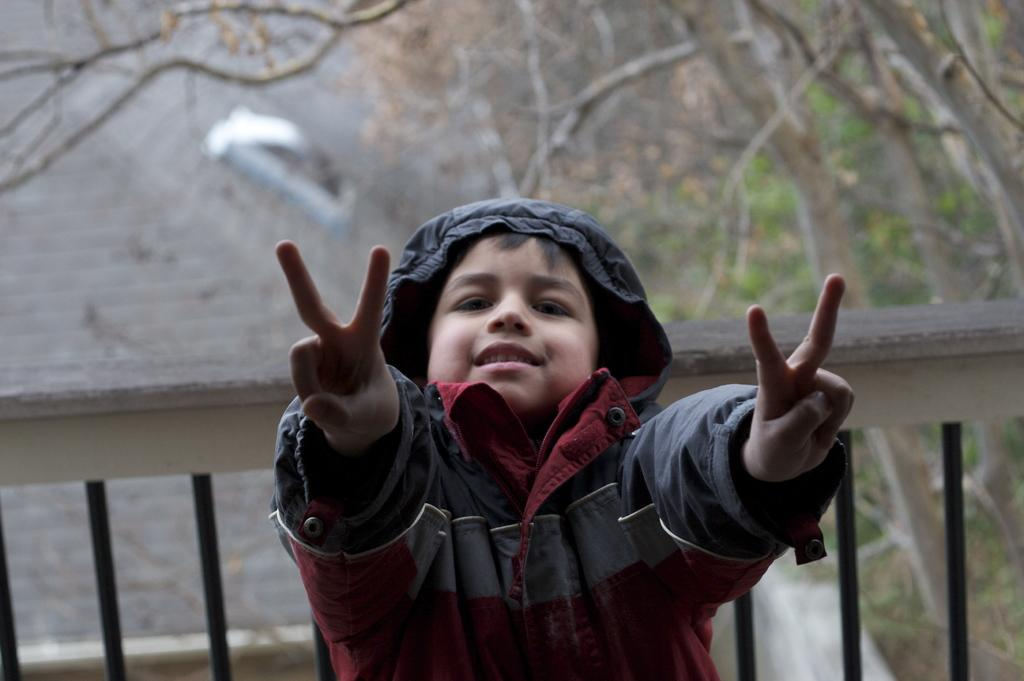Who is the main subject in the image? There is a boy in the center of the image. What can be seen in the background of the image? There are trees and a building in the background of the image. What type of sugar is the boy using to smash the trees in the image? There is no sugar or smashing activity present in the image. The boy is simply standing in the center, and the trees and building are in the background. 